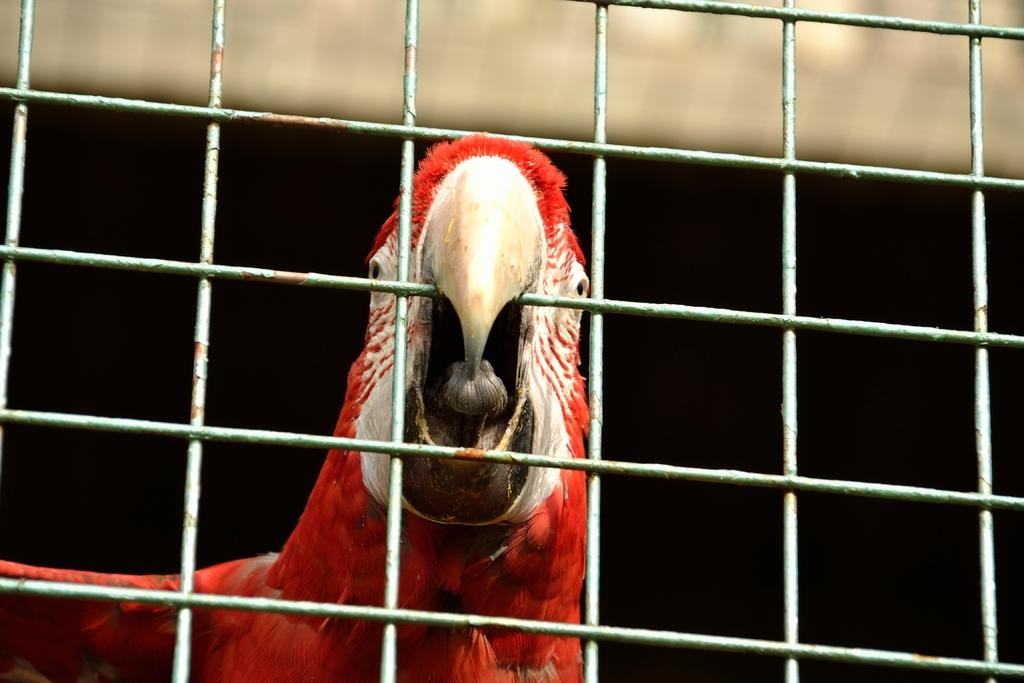What type of animal is in the image? There is a parrot in the image. What material is the grill made of in the image? The grill in the image is made of metal. What type of bone can be seen in the image? There is no bone present in the image. What kind of teeth can be seen on the parrot in the image? Parrots do not have teeth, so there are no teeth visible on the parrot in the image. 